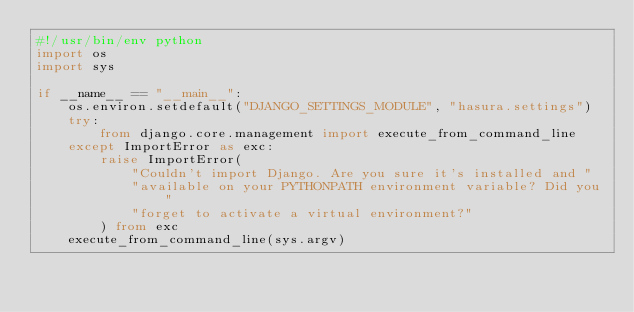Convert code to text. <code><loc_0><loc_0><loc_500><loc_500><_Python_>#!/usr/bin/env python
import os
import sys

if __name__ == "__main__":
    os.environ.setdefault("DJANGO_SETTINGS_MODULE", "hasura.settings")
    try:
        from django.core.management import execute_from_command_line
    except ImportError as exc:
        raise ImportError(
            "Couldn't import Django. Are you sure it's installed and "
            "available on your PYTHONPATH environment variable? Did you "
            "forget to activate a virtual environment?"
        ) from exc
    execute_from_command_line(sys.argv)
</code> 